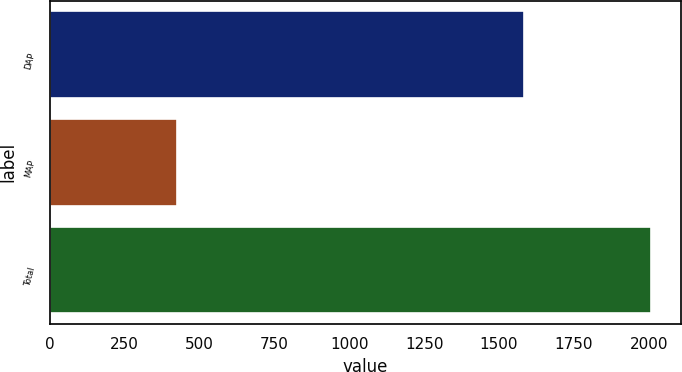Convert chart. <chart><loc_0><loc_0><loc_500><loc_500><bar_chart><fcel>DAP<fcel>MAP<fcel>Total<nl><fcel>1583<fcel>426<fcel>2009<nl></chart> 